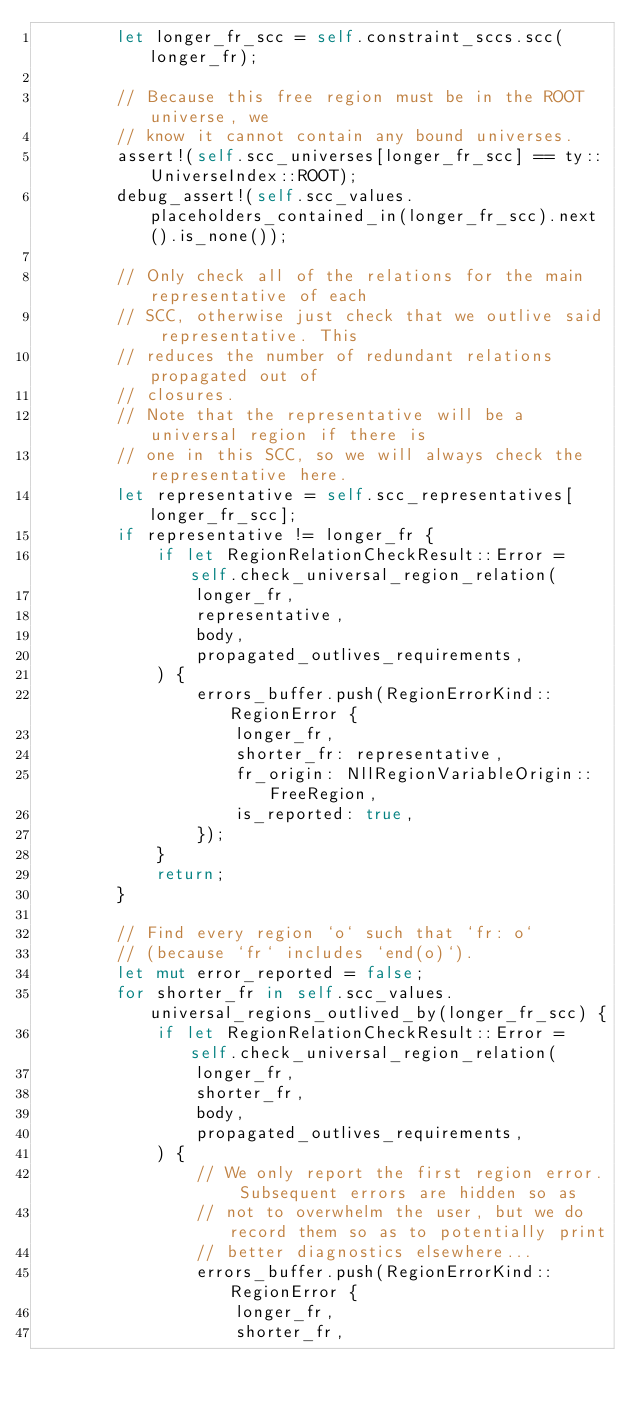<code> <loc_0><loc_0><loc_500><loc_500><_Rust_>        let longer_fr_scc = self.constraint_sccs.scc(longer_fr);

        // Because this free region must be in the ROOT universe, we
        // know it cannot contain any bound universes.
        assert!(self.scc_universes[longer_fr_scc] == ty::UniverseIndex::ROOT);
        debug_assert!(self.scc_values.placeholders_contained_in(longer_fr_scc).next().is_none());

        // Only check all of the relations for the main representative of each
        // SCC, otherwise just check that we outlive said representative. This
        // reduces the number of redundant relations propagated out of
        // closures.
        // Note that the representative will be a universal region if there is
        // one in this SCC, so we will always check the representative here.
        let representative = self.scc_representatives[longer_fr_scc];
        if representative != longer_fr {
            if let RegionRelationCheckResult::Error = self.check_universal_region_relation(
                longer_fr,
                representative,
                body,
                propagated_outlives_requirements,
            ) {
                errors_buffer.push(RegionErrorKind::RegionError {
                    longer_fr,
                    shorter_fr: representative,
                    fr_origin: NllRegionVariableOrigin::FreeRegion,
                    is_reported: true,
                });
            }
            return;
        }

        // Find every region `o` such that `fr: o`
        // (because `fr` includes `end(o)`).
        let mut error_reported = false;
        for shorter_fr in self.scc_values.universal_regions_outlived_by(longer_fr_scc) {
            if let RegionRelationCheckResult::Error = self.check_universal_region_relation(
                longer_fr,
                shorter_fr,
                body,
                propagated_outlives_requirements,
            ) {
                // We only report the first region error. Subsequent errors are hidden so as
                // not to overwhelm the user, but we do record them so as to potentially print
                // better diagnostics elsewhere...
                errors_buffer.push(RegionErrorKind::RegionError {
                    longer_fr,
                    shorter_fr,</code> 